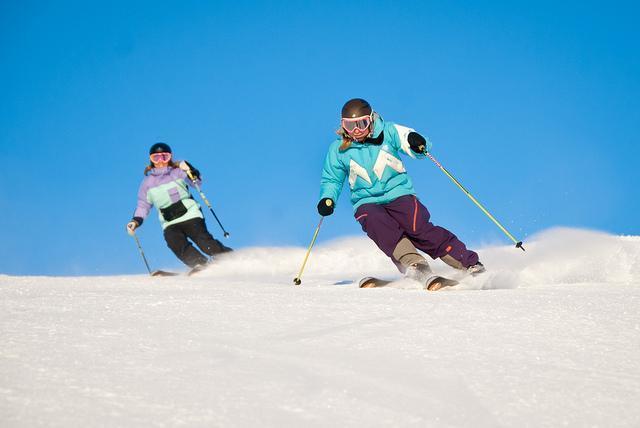How many people are there?
Give a very brief answer. 2. 